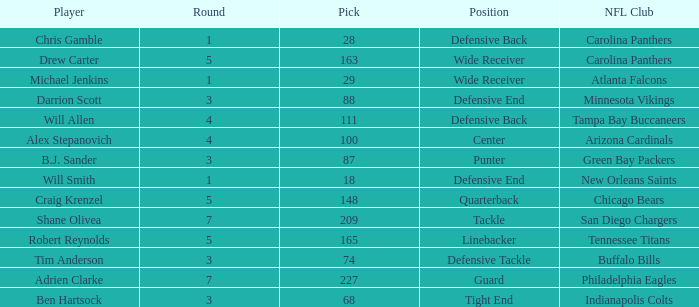What is the highest round number of a Pick after 209. 7.0. 